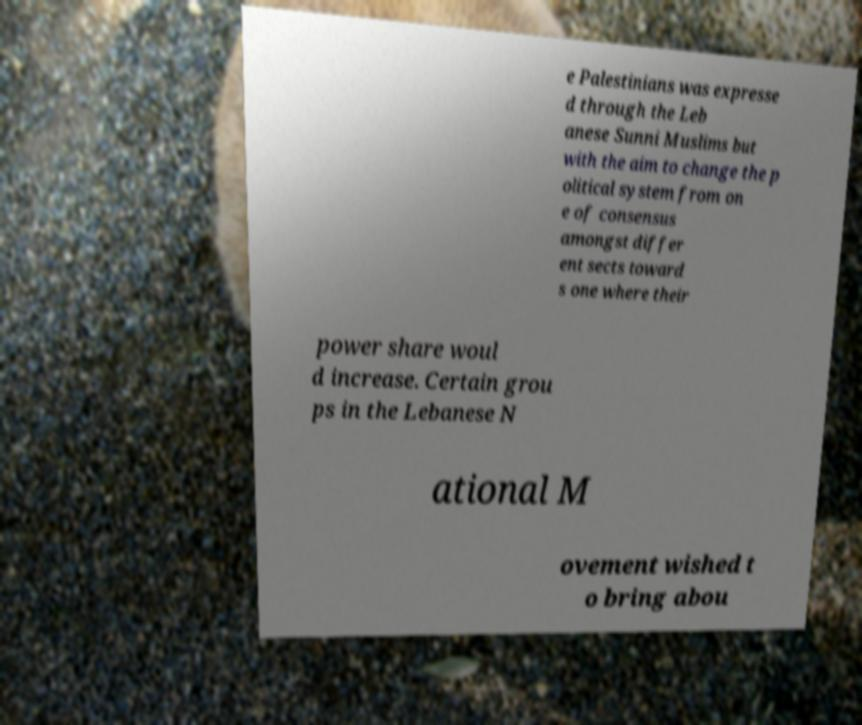Could you extract and type out the text from this image? e Palestinians was expresse d through the Leb anese Sunni Muslims but with the aim to change the p olitical system from on e of consensus amongst differ ent sects toward s one where their power share woul d increase. Certain grou ps in the Lebanese N ational M ovement wished t o bring abou 